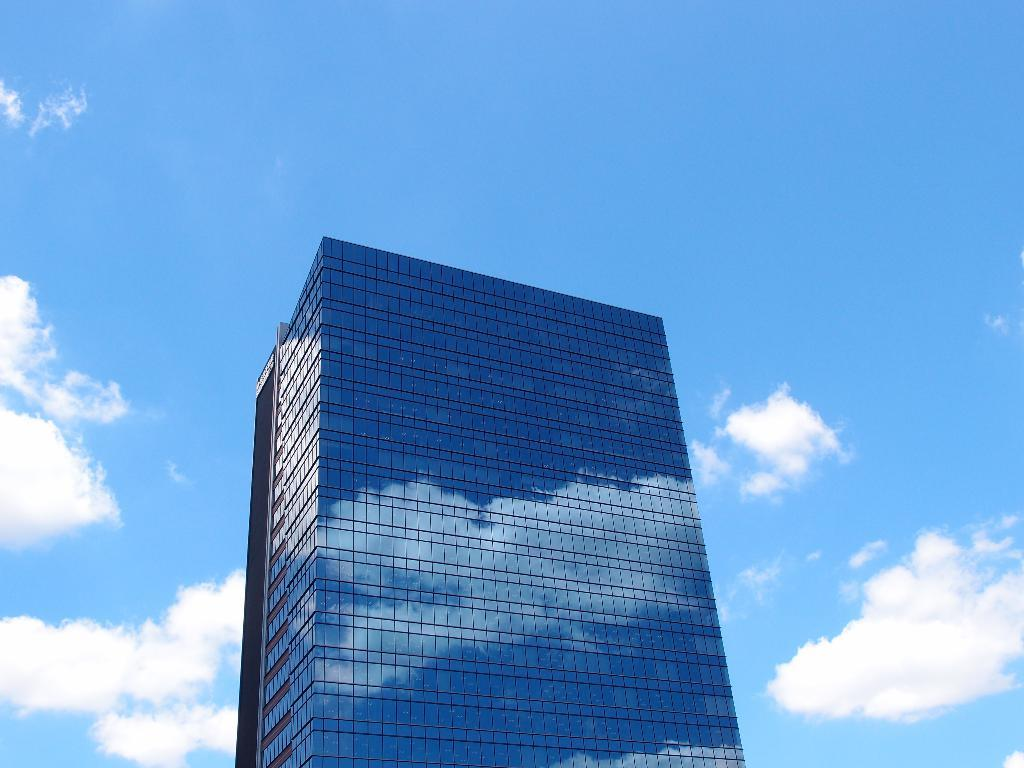What is the main subject in the center of the image? There is a building in the center of the image. What can be seen at the top of the image? The sky is visible at the top of the image. How many beggars are present at the border of the image? There are no beggars or borders present in the image; it features a building and the sky. 